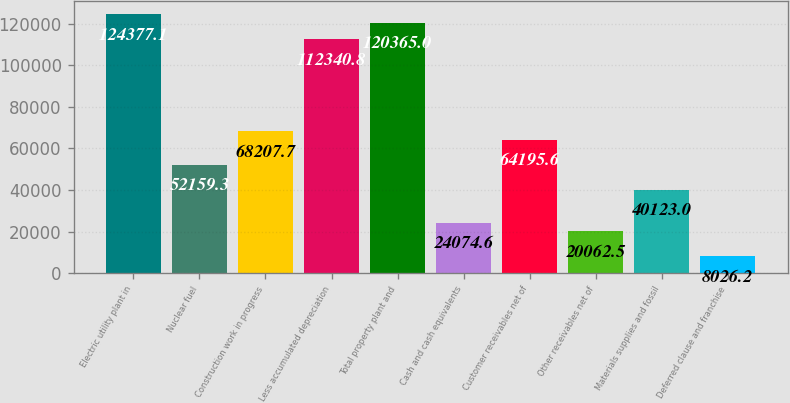Convert chart. <chart><loc_0><loc_0><loc_500><loc_500><bar_chart><fcel>Electric utility plant in<fcel>Nuclear fuel<fcel>Construction work in progress<fcel>Less accumulated depreciation<fcel>Total property plant and<fcel>Cash and cash equivalents<fcel>Customer receivables net of<fcel>Other receivables net of<fcel>Materials supplies and fossil<fcel>Deferred clause and franchise<nl><fcel>124377<fcel>52159.3<fcel>68207.7<fcel>112341<fcel>120365<fcel>24074.6<fcel>64195.6<fcel>20062.5<fcel>40123<fcel>8026.2<nl></chart> 